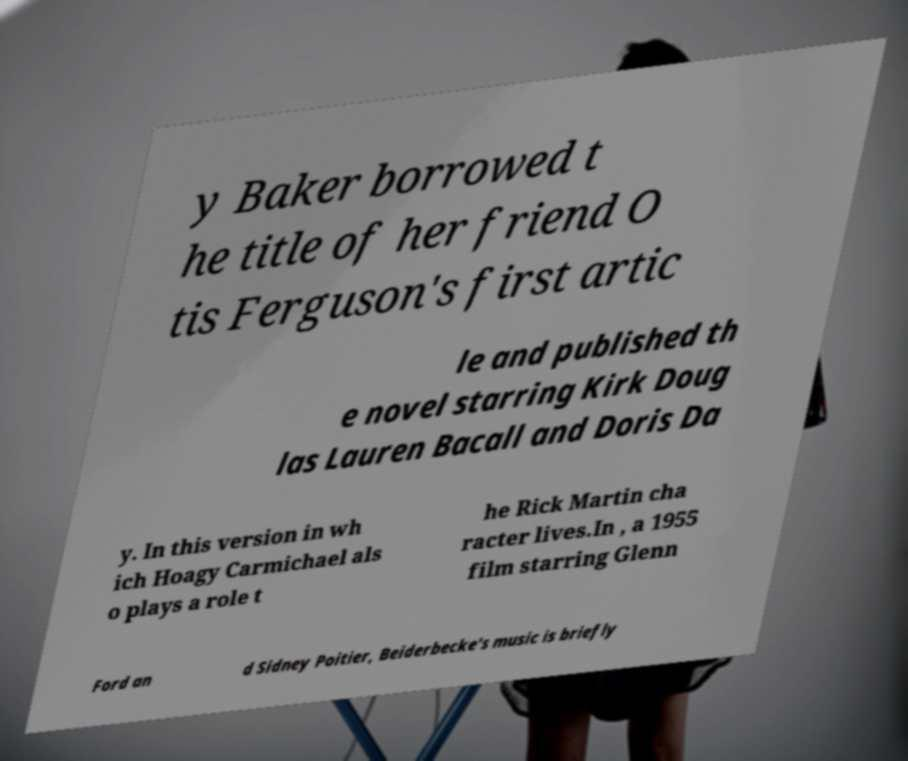Please identify and transcribe the text found in this image. y Baker borrowed t he title of her friend O tis Ferguson's first artic le and published th e novel starring Kirk Doug las Lauren Bacall and Doris Da y. In this version in wh ich Hoagy Carmichael als o plays a role t he Rick Martin cha racter lives.In , a 1955 film starring Glenn Ford an d Sidney Poitier, Beiderbecke's music is briefly 